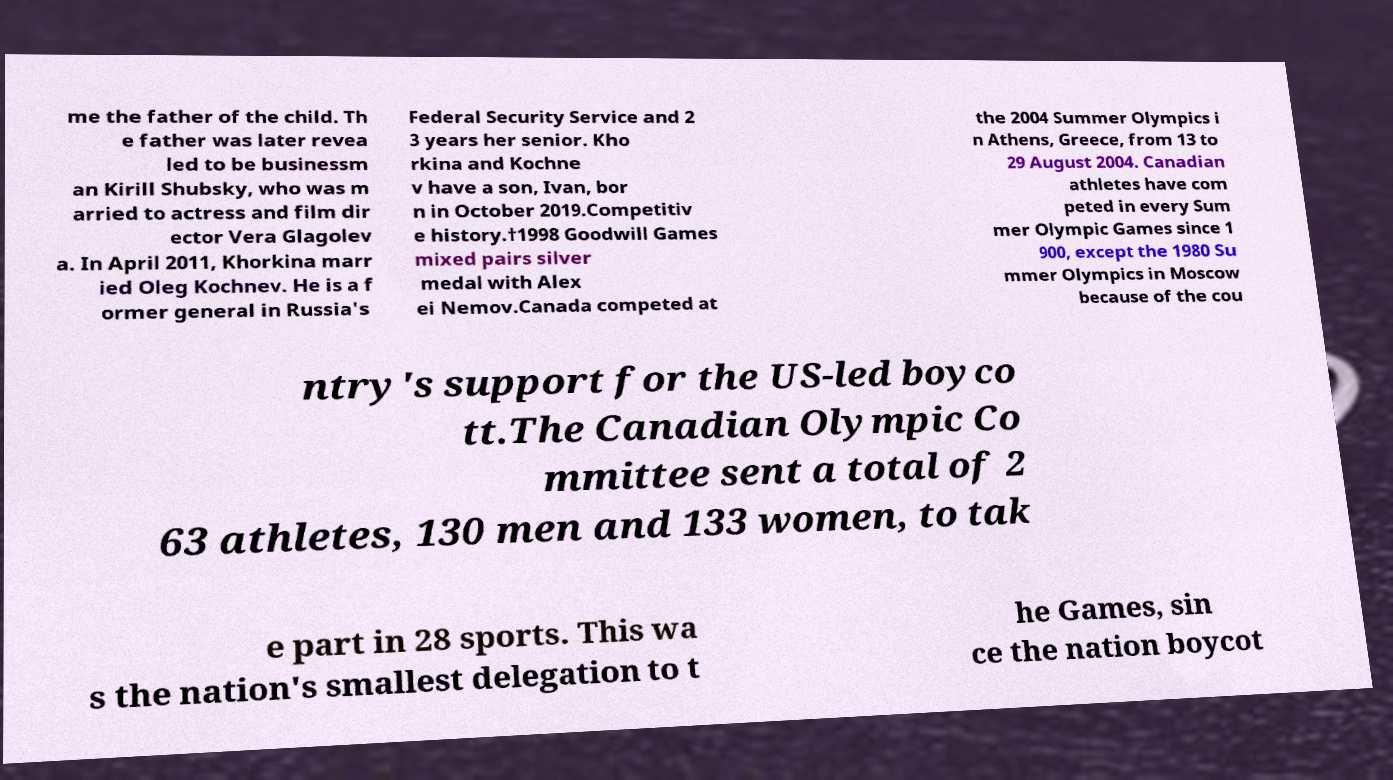Could you assist in decoding the text presented in this image and type it out clearly? me the father of the child. Th e father was later revea led to be businessm an Kirill Shubsky, who was m arried to actress and film dir ector Vera Glagolev a. In April 2011, Khorkina marr ied Oleg Kochnev. He is a f ormer general in Russia's Federal Security Service and 2 3 years her senior. Kho rkina and Kochne v have a son, Ivan, bor n in October 2019.Competitiv e history.†1998 Goodwill Games mixed pairs silver medal with Alex ei Nemov.Canada competed at the 2004 Summer Olympics i n Athens, Greece, from 13 to 29 August 2004. Canadian athletes have com peted in every Sum mer Olympic Games since 1 900, except the 1980 Su mmer Olympics in Moscow because of the cou ntry's support for the US-led boyco tt.The Canadian Olympic Co mmittee sent a total of 2 63 athletes, 130 men and 133 women, to tak e part in 28 sports. This wa s the nation's smallest delegation to t he Games, sin ce the nation boycot 